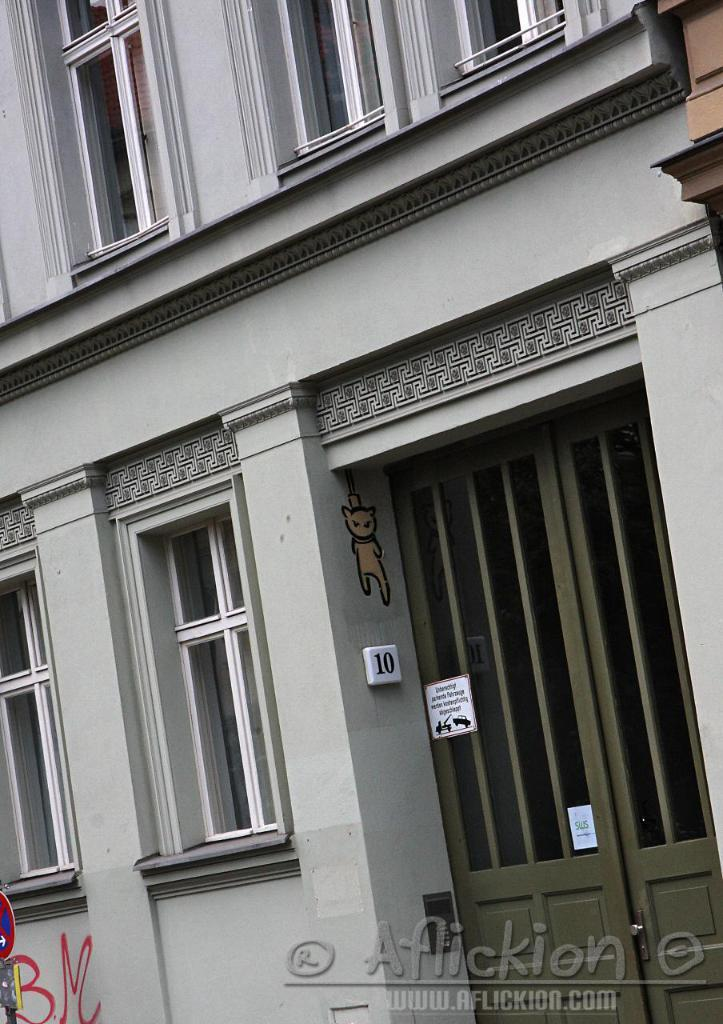What type of structure is visible in the image? There is a building with windows in the image. What can be found at the bottom of the image? There is a watermark at the bottom of the image. What is another object visible in the image? There is a signboard in the image. What is the opinion of the farmer standing near the edge of the building in the image? There is no farmer or edge present in the image, so it is not possible to determine their opinion. 